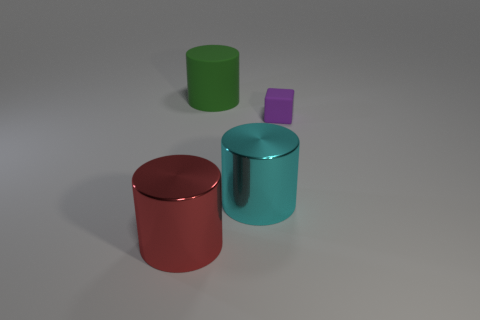Are there any large red shiny objects of the same shape as the small rubber thing?
Your answer should be compact. No. Does the big green rubber object have the same shape as the large cyan shiny object?
Offer a terse response. Yes. What number of large things are either purple things or shiny things?
Provide a succinct answer. 2. Are there more large cyan metal things than cylinders?
Provide a short and direct response. No. What is the size of the green thing that is the same material as the cube?
Provide a succinct answer. Large. There is a metal object that is left of the green cylinder; is it the same size as the matte thing to the left of the large cyan metal cylinder?
Ensure brevity in your answer.  Yes. How many things are big shiny cylinders in front of the cyan metal cylinder or small green matte cylinders?
Provide a succinct answer. 1. Is the number of tiny objects less than the number of small green matte things?
Offer a very short reply. No. What shape is the metallic thing that is to the right of the object that is on the left side of the big cylinder that is behind the purple rubber cube?
Keep it short and to the point. Cylinder. Are any big cyan cylinders visible?
Offer a terse response. Yes. 